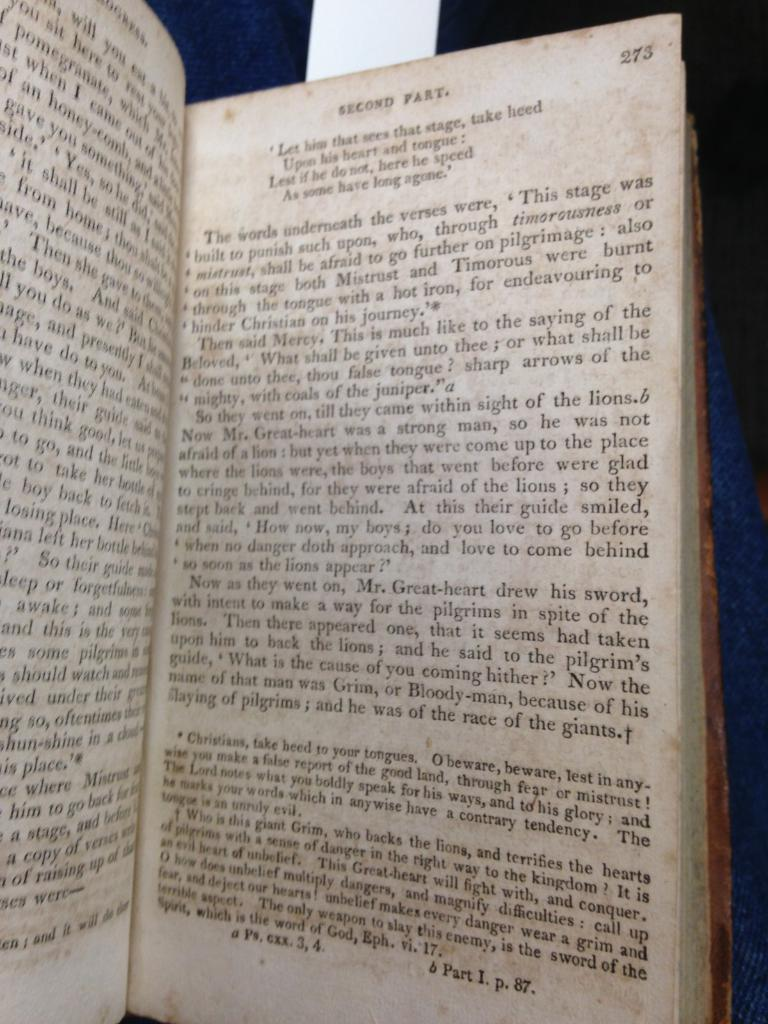<image>
Present a compact description of the photo's key features. The page of a book is labeled at the top as the Second Part. 